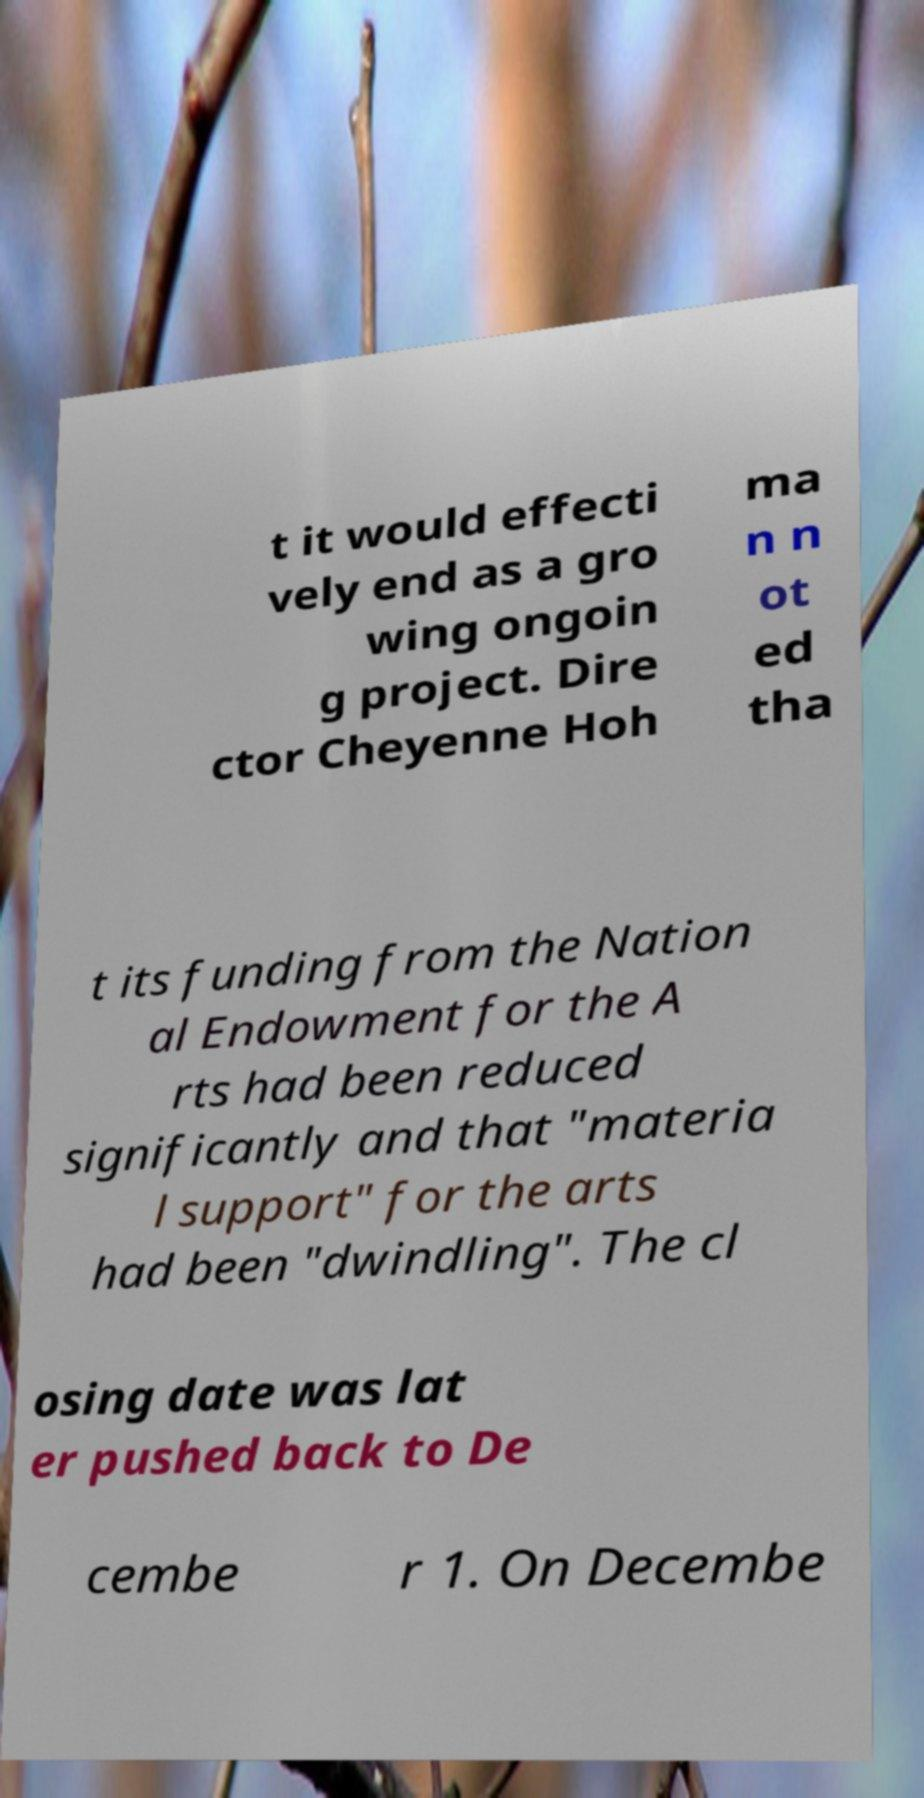Please read and relay the text visible in this image. What does it say? t it would effecti vely end as a gro wing ongoin g project. Dire ctor Cheyenne Hoh ma n n ot ed tha t its funding from the Nation al Endowment for the A rts had been reduced significantly and that "materia l support" for the arts had been "dwindling". The cl osing date was lat er pushed back to De cembe r 1. On Decembe 